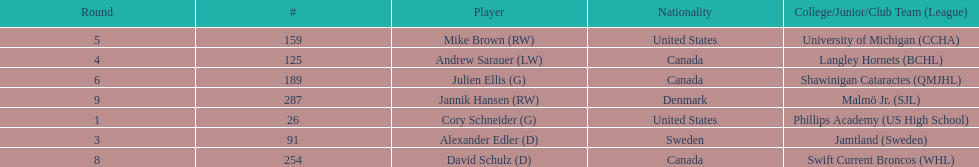How many players are from the united states? 2. 